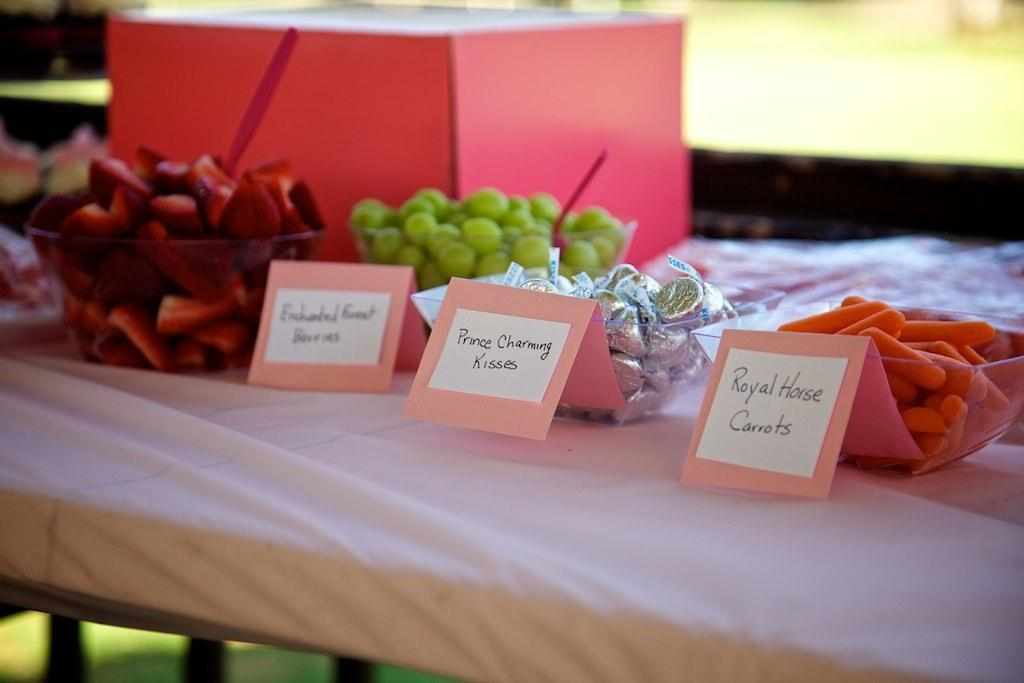What type of objects with text can be seen in the image? There are cards with text in the image. What else is present in the image besides the cards? There are food items placed on a surface in the image. What type of clouds can be seen in the image? There are no clouds present in the image; it features cards with text and food items. What type of soap is used to clean the food items in the image? There is no soap or cleaning activity depicted in the image. 